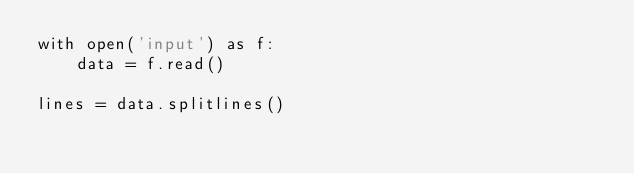<code> <loc_0><loc_0><loc_500><loc_500><_Python_>with open('input') as f:
    data = f.read()

lines = data.splitlines()</code> 